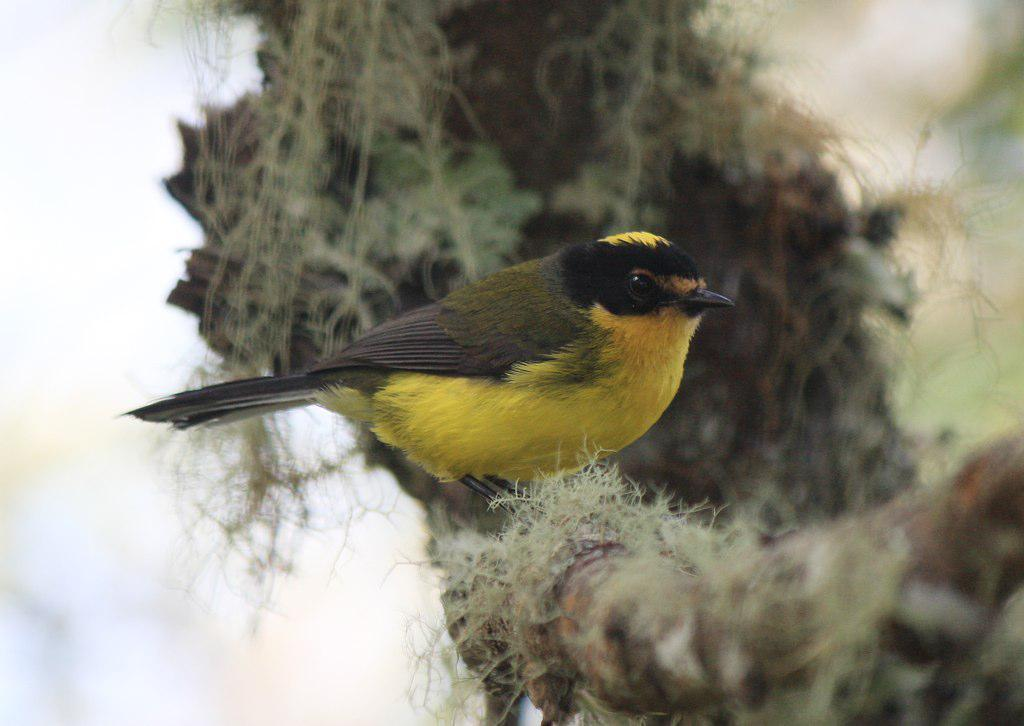What type of animal is in the image? There is a bird in the image. What is the bird perched on? The bird is on a wooden bamboo-like object. Can you describe the background of the image? The background of the image is blurry. What type of shirt is the bird wearing in the image? There is no shirt present in the image, as birds do not wear clothing. 